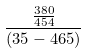Convert formula to latex. <formula><loc_0><loc_0><loc_500><loc_500>\frac { \frac { 3 8 0 } { 4 5 4 } } { ( 3 5 - 4 6 5 ) }</formula> 